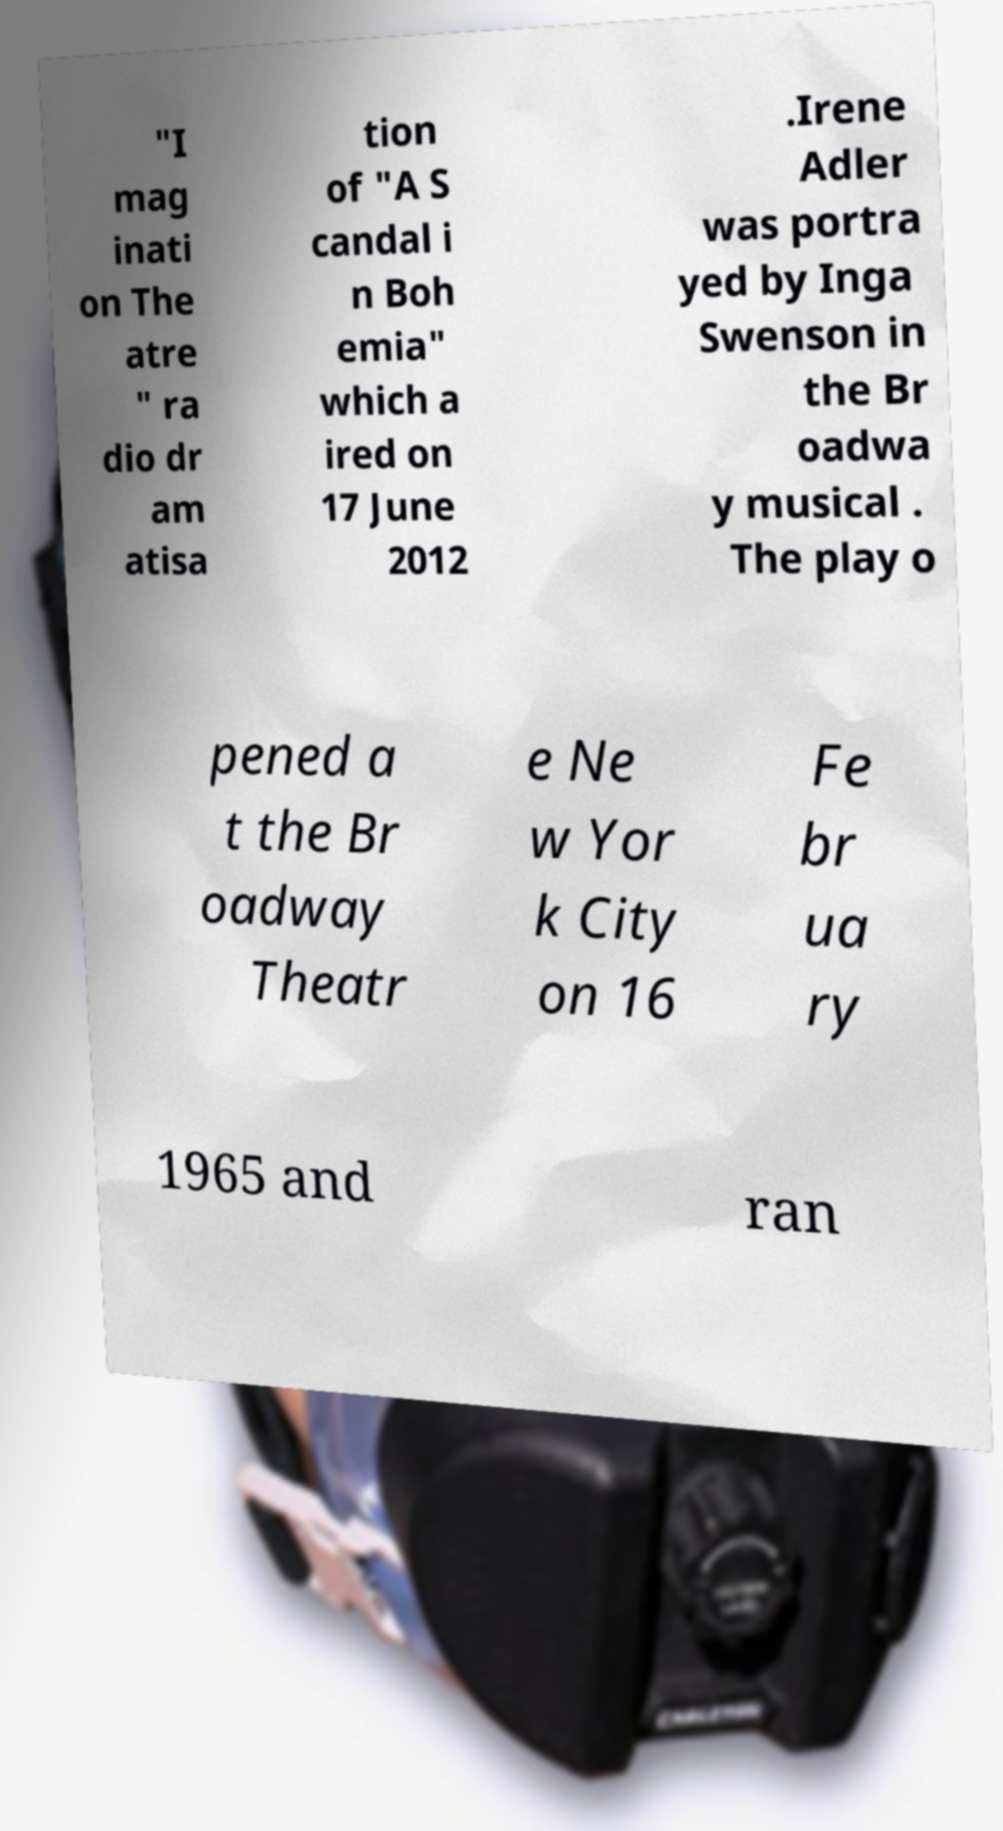Can you read and provide the text displayed in the image?This photo seems to have some interesting text. Can you extract and type it out for me? "I mag inati on The atre " ra dio dr am atisa tion of "A S candal i n Boh emia" which a ired on 17 June 2012 .Irene Adler was portra yed by Inga Swenson in the Br oadwa y musical . The play o pened a t the Br oadway Theatr e Ne w Yor k City on 16 Fe br ua ry 1965 and ran 